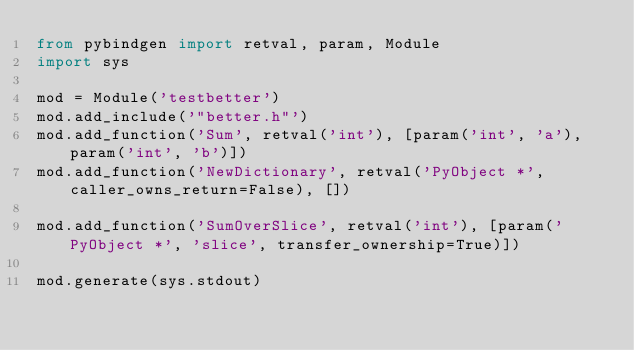Convert code to text. <code><loc_0><loc_0><loc_500><loc_500><_Python_>from pybindgen import retval, param, Module
import sys

mod = Module('testbetter')
mod.add_include('"better.h"')
mod.add_function('Sum', retval('int'), [param('int', 'a'), param('int', 'b')])
mod.add_function('NewDictionary', retval('PyObject *', caller_owns_return=False), [])

mod.add_function('SumOverSlice', retval('int'), [param('PyObject *', 'slice', transfer_ownership=True)])

mod.generate(sys.stdout)</code> 